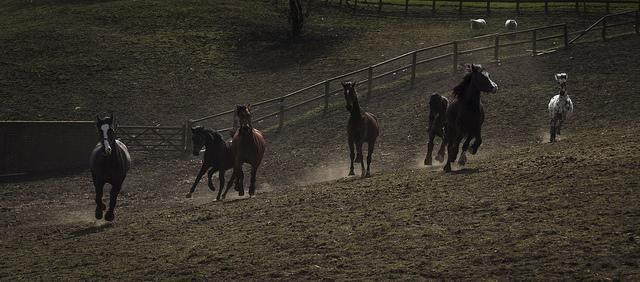What is used to keep the horses in one area?

Choices:
A) trees
B) dogs
C) fences
D) guns fences 